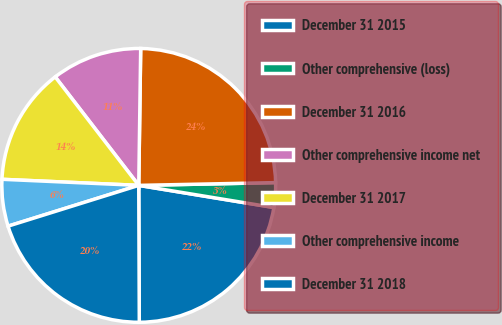Convert chart to OTSL. <chart><loc_0><loc_0><loc_500><loc_500><pie_chart><fcel>December 31 2015<fcel>Other comprehensive (loss)<fcel>December 31 2016<fcel>Other comprehensive income net<fcel>December 31 2017<fcel>Other comprehensive income<fcel>December 31 2018<nl><fcel>22.35%<fcel>2.91%<fcel>24.45%<fcel>10.67%<fcel>13.85%<fcel>5.52%<fcel>20.25%<nl></chart> 